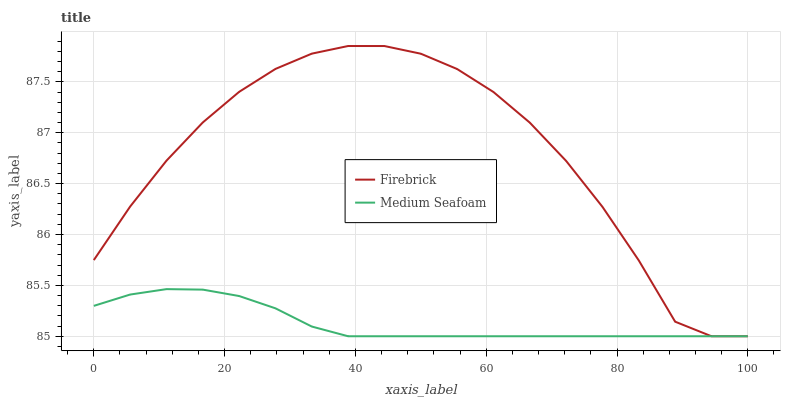Does Medium Seafoam have the minimum area under the curve?
Answer yes or no. Yes. Does Firebrick have the maximum area under the curve?
Answer yes or no. Yes. Does Medium Seafoam have the maximum area under the curve?
Answer yes or no. No. Is Medium Seafoam the smoothest?
Answer yes or no. Yes. Is Firebrick the roughest?
Answer yes or no. Yes. Is Medium Seafoam the roughest?
Answer yes or no. No. Does Firebrick have the lowest value?
Answer yes or no. Yes. Does Firebrick have the highest value?
Answer yes or no. Yes. Does Medium Seafoam have the highest value?
Answer yes or no. No. Does Firebrick intersect Medium Seafoam?
Answer yes or no. Yes. Is Firebrick less than Medium Seafoam?
Answer yes or no. No. Is Firebrick greater than Medium Seafoam?
Answer yes or no. No. 